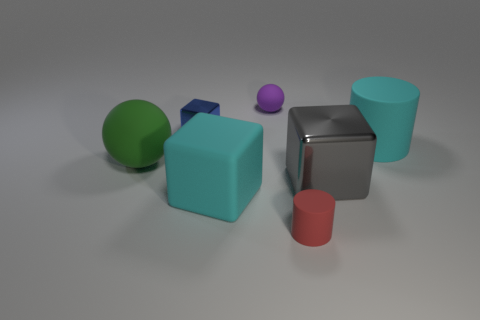Add 3 small purple rubber things. How many objects exist? 10 Subtract all spheres. How many objects are left? 5 Add 3 green spheres. How many green spheres exist? 4 Subtract 1 red cylinders. How many objects are left? 6 Subtract all tiny yellow shiny cylinders. Subtract all big green matte objects. How many objects are left? 6 Add 2 gray shiny cubes. How many gray shiny cubes are left? 3 